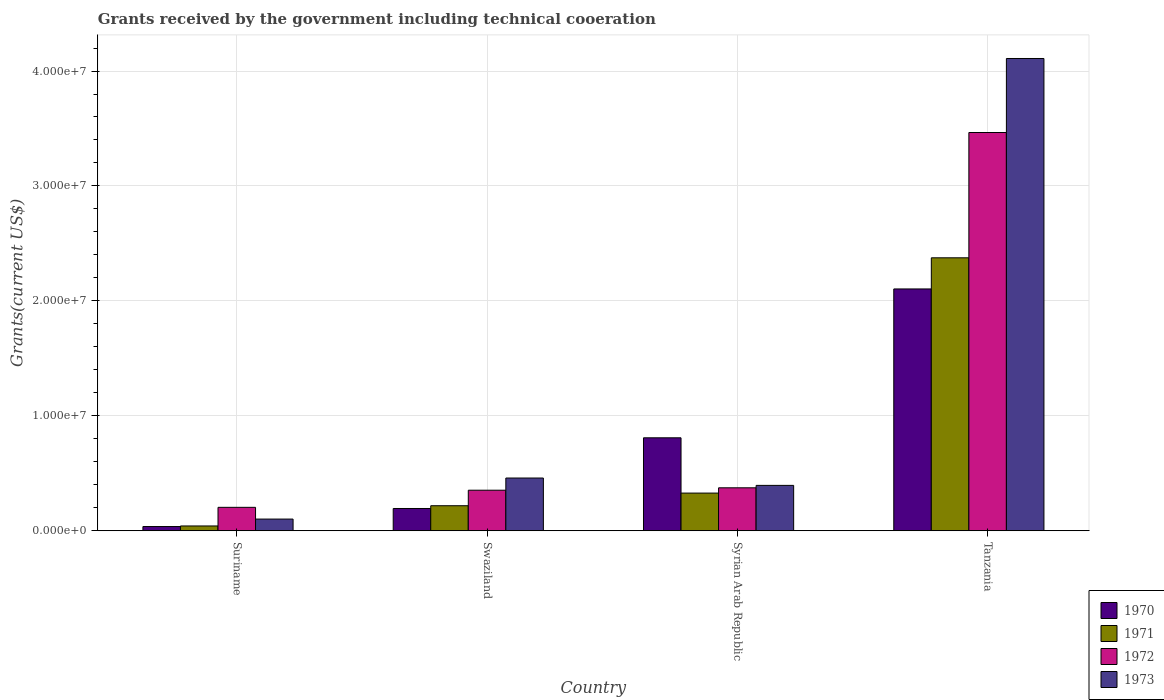Are the number of bars per tick equal to the number of legend labels?
Your answer should be very brief. Yes. Are the number of bars on each tick of the X-axis equal?
Offer a very short reply. Yes. What is the label of the 4th group of bars from the left?
Your answer should be very brief. Tanzania. In how many cases, is the number of bars for a given country not equal to the number of legend labels?
Provide a succinct answer. 0. What is the total grants received by the government in 1973 in Suriname?
Provide a short and direct response. 1.02e+06. Across all countries, what is the maximum total grants received by the government in 1972?
Offer a very short reply. 3.46e+07. In which country was the total grants received by the government in 1971 maximum?
Offer a terse response. Tanzania. In which country was the total grants received by the government in 1970 minimum?
Ensure brevity in your answer.  Suriname. What is the total total grants received by the government in 1972 in the graph?
Your answer should be compact. 4.40e+07. What is the difference between the total grants received by the government in 1973 in Suriname and that in Swaziland?
Your response must be concise. -3.57e+06. What is the difference between the total grants received by the government in 1971 in Tanzania and the total grants received by the government in 1973 in Syrian Arab Republic?
Your response must be concise. 1.98e+07. What is the average total grants received by the government in 1970 per country?
Provide a short and direct response. 7.86e+06. What is the difference between the total grants received by the government of/in 1971 and total grants received by the government of/in 1970 in Tanzania?
Your answer should be compact. 2.71e+06. In how many countries, is the total grants received by the government in 1973 greater than 14000000 US$?
Make the answer very short. 1. What is the ratio of the total grants received by the government in 1970 in Suriname to that in Tanzania?
Give a very brief answer. 0.02. Is the total grants received by the government in 1970 in Syrian Arab Republic less than that in Tanzania?
Your answer should be very brief. Yes. What is the difference between the highest and the second highest total grants received by the government in 1972?
Your response must be concise. 3.11e+07. What is the difference between the highest and the lowest total grants received by the government in 1971?
Provide a succinct answer. 2.33e+07. In how many countries, is the total grants received by the government in 1972 greater than the average total grants received by the government in 1972 taken over all countries?
Provide a short and direct response. 1. Is it the case that in every country, the sum of the total grants received by the government in 1971 and total grants received by the government in 1973 is greater than the sum of total grants received by the government in 1970 and total grants received by the government in 1972?
Your answer should be very brief. No. Is it the case that in every country, the sum of the total grants received by the government in 1970 and total grants received by the government in 1971 is greater than the total grants received by the government in 1972?
Ensure brevity in your answer.  No. How many bars are there?
Give a very brief answer. 16. Are the values on the major ticks of Y-axis written in scientific E-notation?
Ensure brevity in your answer.  Yes. Does the graph contain any zero values?
Your answer should be very brief. No. Where does the legend appear in the graph?
Provide a short and direct response. Bottom right. What is the title of the graph?
Offer a terse response. Grants received by the government including technical cooeration. What is the label or title of the X-axis?
Offer a terse response. Country. What is the label or title of the Y-axis?
Give a very brief answer. Grants(current US$). What is the Grants(current US$) in 1970 in Suriname?
Ensure brevity in your answer.  3.70e+05. What is the Grants(current US$) of 1971 in Suriname?
Offer a very short reply. 4.20e+05. What is the Grants(current US$) of 1972 in Suriname?
Your answer should be compact. 2.04e+06. What is the Grants(current US$) of 1973 in Suriname?
Your answer should be compact. 1.02e+06. What is the Grants(current US$) of 1970 in Swaziland?
Keep it short and to the point. 1.94e+06. What is the Grants(current US$) of 1971 in Swaziland?
Your answer should be very brief. 2.18e+06. What is the Grants(current US$) in 1972 in Swaziland?
Offer a terse response. 3.53e+06. What is the Grants(current US$) of 1973 in Swaziland?
Your answer should be very brief. 4.59e+06. What is the Grants(current US$) in 1970 in Syrian Arab Republic?
Your response must be concise. 8.09e+06. What is the Grants(current US$) in 1971 in Syrian Arab Republic?
Give a very brief answer. 3.28e+06. What is the Grants(current US$) of 1972 in Syrian Arab Republic?
Provide a succinct answer. 3.74e+06. What is the Grants(current US$) in 1973 in Syrian Arab Republic?
Provide a short and direct response. 3.95e+06. What is the Grants(current US$) in 1970 in Tanzania?
Your answer should be compact. 2.10e+07. What is the Grants(current US$) in 1971 in Tanzania?
Your answer should be very brief. 2.38e+07. What is the Grants(current US$) of 1972 in Tanzania?
Your answer should be compact. 3.46e+07. What is the Grants(current US$) in 1973 in Tanzania?
Give a very brief answer. 4.11e+07. Across all countries, what is the maximum Grants(current US$) in 1970?
Ensure brevity in your answer.  2.10e+07. Across all countries, what is the maximum Grants(current US$) of 1971?
Keep it short and to the point. 2.38e+07. Across all countries, what is the maximum Grants(current US$) in 1972?
Keep it short and to the point. 3.46e+07. Across all countries, what is the maximum Grants(current US$) in 1973?
Provide a short and direct response. 4.11e+07. Across all countries, what is the minimum Grants(current US$) in 1970?
Your answer should be very brief. 3.70e+05. Across all countries, what is the minimum Grants(current US$) in 1972?
Ensure brevity in your answer.  2.04e+06. Across all countries, what is the minimum Grants(current US$) in 1973?
Provide a short and direct response. 1.02e+06. What is the total Grants(current US$) in 1970 in the graph?
Ensure brevity in your answer.  3.14e+07. What is the total Grants(current US$) of 1971 in the graph?
Provide a succinct answer. 2.96e+07. What is the total Grants(current US$) of 1972 in the graph?
Keep it short and to the point. 4.40e+07. What is the total Grants(current US$) in 1973 in the graph?
Offer a terse response. 5.06e+07. What is the difference between the Grants(current US$) of 1970 in Suriname and that in Swaziland?
Your answer should be compact. -1.57e+06. What is the difference between the Grants(current US$) in 1971 in Suriname and that in Swaziland?
Your answer should be very brief. -1.76e+06. What is the difference between the Grants(current US$) in 1972 in Suriname and that in Swaziland?
Provide a short and direct response. -1.49e+06. What is the difference between the Grants(current US$) of 1973 in Suriname and that in Swaziland?
Your answer should be compact. -3.57e+06. What is the difference between the Grants(current US$) of 1970 in Suriname and that in Syrian Arab Republic?
Provide a short and direct response. -7.72e+06. What is the difference between the Grants(current US$) of 1971 in Suriname and that in Syrian Arab Republic?
Offer a very short reply. -2.86e+06. What is the difference between the Grants(current US$) in 1972 in Suriname and that in Syrian Arab Republic?
Provide a succinct answer. -1.70e+06. What is the difference between the Grants(current US$) in 1973 in Suriname and that in Syrian Arab Republic?
Your answer should be very brief. -2.93e+06. What is the difference between the Grants(current US$) in 1970 in Suriname and that in Tanzania?
Your answer should be very brief. -2.07e+07. What is the difference between the Grants(current US$) in 1971 in Suriname and that in Tanzania?
Ensure brevity in your answer.  -2.33e+07. What is the difference between the Grants(current US$) of 1972 in Suriname and that in Tanzania?
Your response must be concise. -3.26e+07. What is the difference between the Grants(current US$) in 1973 in Suriname and that in Tanzania?
Your answer should be compact. -4.01e+07. What is the difference between the Grants(current US$) in 1970 in Swaziland and that in Syrian Arab Republic?
Provide a short and direct response. -6.15e+06. What is the difference between the Grants(current US$) in 1971 in Swaziland and that in Syrian Arab Republic?
Offer a terse response. -1.10e+06. What is the difference between the Grants(current US$) of 1973 in Swaziland and that in Syrian Arab Republic?
Make the answer very short. 6.40e+05. What is the difference between the Grants(current US$) of 1970 in Swaziland and that in Tanzania?
Offer a terse response. -1.91e+07. What is the difference between the Grants(current US$) in 1971 in Swaziland and that in Tanzania?
Ensure brevity in your answer.  -2.16e+07. What is the difference between the Grants(current US$) of 1972 in Swaziland and that in Tanzania?
Your answer should be very brief. -3.11e+07. What is the difference between the Grants(current US$) of 1973 in Swaziland and that in Tanzania?
Make the answer very short. -3.65e+07. What is the difference between the Grants(current US$) of 1970 in Syrian Arab Republic and that in Tanzania?
Offer a very short reply. -1.30e+07. What is the difference between the Grants(current US$) in 1971 in Syrian Arab Republic and that in Tanzania?
Provide a short and direct response. -2.05e+07. What is the difference between the Grants(current US$) in 1972 in Syrian Arab Republic and that in Tanzania?
Keep it short and to the point. -3.09e+07. What is the difference between the Grants(current US$) in 1973 in Syrian Arab Republic and that in Tanzania?
Keep it short and to the point. -3.71e+07. What is the difference between the Grants(current US$) in 1970 in Suriname and the Grants(current US$) in 1971 in Swaziland?
Offer a terse response. -1.81e+06. What is the difference between the Grants(current US$) in 1970 in Suriname and the Grants(current US$) in 1972 in Swaziland?
Your response must be concise. -3.16e+06. What is the difference between the Grants(current US$) in 1970 in Suriname and the Grants(current US$) in 1973 in Swaziland?
Provide a short and direct response. -4.22e+06. What is the difference between the Grants(current US$) of 1971 in Suriname and the Grants(current US$) of 1972 in Swaziland?
Your answer should be very brief. -3.11e+06. What is the difference between the Grants(current US$) of 1971 in Suriname and the Grants(current US$) of 1973 in Swaziland?
Ensure brevity in your answer.  -4.17e+06. What is the difference between the Grants(current US$) of 1972 in Suriname and the Grants(current US$) of 1973 in Swaziland?
Your response must be concise. -2.55e+06. What is the difference between the Grants(current US$) in 1970 in Suriname and the Grants(current US$) in 1971 in Syrian Arab Republic?
Your answer should be very brief. -2.91e+06. What is the difference between the Grants(current US$) in 1970 in Suriname and the Grants(current US$) in 1972 in Syrian Arab Republic?
Give a very brief answer. -3.37e+06. What is the difference between the Grants(current US$) of 1970 in Suriname and the Grants(current US$) of 1973 in Syrian Arab Republic?
Provide a succinct answer. -3.58e+06. What is the difference between the Grants(current US$) in 1971 in Suriname and the Grants(current US$) in 1972 in Syrian Arab Republic?
Offer a very short reply. -3.32e+06. What is the difference between the Grants(current US$) in 1971 in Suriname and the Grants(current US$) in 1973 in Syrian Arab Republic?
Provide a succinct answer. -3.53e+06. What is the difference between the Grants(current US$) of 1972 in Suriname and the Grants(current US$) of 1973 in Syrian Arab Republic?
Make the answer very short. -1.91e+06. What is the difference between the Grants(current US$) of 1970 in Suriname and the Grants(current US$) of 1971 in Tanzania?
Offer a very short reply. -2.34e+07. What is the difference between the Grants(current US$) of 1970 in Suriname and the Grants(current US$) of 1972 in Tanzania?
Ensure brevity in your answer.  -3.43e+07. What is the difference between the Grants(current US$) in 1970 in Suriname and the Grants(current US$) in 1973 in Tanzania?
Keep it short and to the point. -4.07e+07. What is the difference between the Grants(current US$) in 1971 in Suriname and the Grants(current US$) in 1972 in Tanzania?
Offer a terse response. -3.42e+07. What is the difference between the Grants(current US$) of 1971 in Suriname and the Grants(current US$) of 1973 in Tanzania?
Offer a terse response. -4.07e+07. What is the difference between the Grants(current US$) in 1972 in Suriname and the Grants(current US$) in 1973 in Tanzania?
Offer a terse response. -3.90e+07. What is the difference between the Grants(current US$) of 1970 in Swaziland and the Grants(current US$) of 1971 in Syrian Arab Republic?
Your response must be concise. -1.34e+06. What is the difference between the Grants(current US$) in 1970 in Swaziland and the Grants(current US$) in 1972 in Syrian Arab Republic?
Your response must be concise. -1.80e+06. What is the difference between the Grants(current US$) in 1970 in Swaziland and the Grants(current US$) in 1973 in Syrian Arab Republic?
Ensure brevity in your answer.  -2.01e+06. What is the difference between the Grants(current US$) in 1971 in Swaziland and the Grants(current US$) in 1972 in Syrian Arab Republic?
Give a very brief answer. -1.56e+06. What is the difference between the Grants(current US$) of 1971 in Swaziland and the Grants(current US$) of 1973 in Syrian Arab Republic?
Offer a very short reply. -1.77e+06. What is the difference between the Grants(current US$) in 1972 in Swaziland and the Grants(current US$) in 1973 in Syrian Arab Republic?
Your answer should be very brief. -4.20e+05. What is the difference between the Grants(current US$) of 1970 in Swaziland and the Grants(current US$) of 1971 in Tanzania?
Your answer should be compact. -2.18e+07. What is the difference between the Grants(current US$) of 1970 in Swaziland and the Grants(current US$) of 1972 in Tanzania?
Offer a very short reply. -3.27e+07. What is the difference between the Grants(current US$) of 1970 in Swaziland and the Grants(current US$) of 1973 in Tanzania?
Your response must be concise. -3.92e+07. What is the difference between the Grants(current US$) in 1971 in Swaziland and the Grants(current US$) in 1972 in Tanzania?
Keep it short and to the point. -3.25e+07. What is the difference between the Grants(current US$) of 1971 in Swaziland and the Grants(current US$) of 1973 in Tanzania?
Your answer should be very brief. -3.89e+07. What is the difference between the Grants(current US$) in 1972 in Swaziland and the Grants(current US$) in 1973 in Tanzania?
Provide a succinct answer. -3.76e+07. What is the difference between the Grants(current US$) in 1970 in Syrian Arab Republic and the Grants(current US$) in 1971 in Tanzania?
Provide a succinct answer. -1.57e+07. What is the difference between the Grants(current US$) of 1970 in Syrian Arab Republic and the Grants(current US$) of 1972 in Tanzania?
Keep it short and to the point. -2.66e+07. What is the difference between the Grants(current US$) in 1970 in Syrian Arab Republic and the Grants(current US$) in 1973 in Tanzania?
Your response must be concise. -3.30e+07. What is the difference between the Grants(current US$) in 1971 in Syrian Arab Republic and the Grants(current US$) in 1972 in Tanzania?
Your answer should be compact. -3.14e+07. What is the difference between the Grants(current US$) in 1971 in Syrian Arab Republic and the Grants(current US$) in 1973 in Tanzania?
Make the answer very short. -3.78e+07. What is the difference between the Grants(current US$) in 1972 in Syrian Arab Republic and the Grants(current US$) in 1973 in Tanzania?
Your response must be concise. -3.74e+07. What is the average Grants(current US$) in 1970 per country?
Your answer should be very brief. 7.86e+06. What is the average Grants(current US$) of 1971 per country?
Keep it short and to the point. 7.41e+06. What is the average Grants(current US$) of 1972 per country?
Offer a very short reply. 1.10e+07. What is the average Grants(current US$) in 1973 per country?
Your response must be concise. 1.27e+07. What is the difference between the Grants(current US$) in 1970 and Grants(current US$) in 1971 in Suriname?
Make the answer very short. -5.00e+04. What is the difference between the Grants(current US$) of 1970 and Grants(current US$) of 1972 in Suriname?
Make the answer very short. -1.67e+06. What is the difference between the Grants(current US$) in 1970 and Grants(current US$) in 1973 in Suriname?
Your answer should be compact. -6.50e+05. What is the difference between the Grants(current US$) in 1971 and Grants(current US$) in 1972 in Suriname?
Your answer should be very brief. -1.62e+06. What is the difference between the Grants(current US$) of 1971 and Grants(current US$) of 1973 in Suriname?
Offer a terse response. -6.00e+05. What is the difference between the Grants(current US$) in 1972 and Grants(current US$) in 1973 in Suriname?
Your response must be concise. 1.02e+06. What is the difference between the Grants(current US$) in 1970 and Grants(current US$) in 1971 in Swaziland?
Offer a very short reply. -2.40e+05. What is the difference between the Grants(current US$) of 1970 and Grants(current US$) of 1972 in Swaziland?
Offer a terse response. -1.59e+06. What is the difference between the Grants(current US$) in 1970 and Grants(current US$) in 1973 in Swaziland?
Offer a very short reply. -2.65e+06. What is the difference between the Grants(current US$) in 1971 and Grants(current US$) in 1972 in Swaziland?
Your answer should be very brief. -1.35e+06. What is the difference between the Grants(current US$) of 1971 and Grants(current US$) of 1973 in Swaziland?
Provide a succinct answer. -2.41e+06. What is the difference between the Grants(current US$) in 1972 and Grants(current US$) in 1973 in Swaziland?
Offer a very short reply. -1.06e+06. What is the difference between the Grants(current US$) of 1970 and Grants(current US$) of 1971 in Syrian Arab Republic?
Make the answer very short. 4.81e+06. What is the difference between the Grants(current US$) in 1970 and Grants(current US$) in 1972 in Syrian Arab Republic?
Make the answer very short. 4.35e+06. What is the difference between the Grants(current US$) of 1970 and Grants(current US$) of 1973 in Syrian Arab Republic?
Provide a short and direct response. 4.14e+06. What is the difference between the Grants(current US$) of 1971 and Grants(current US$) of 1972 in Syrian Arab Republic?
Ensure brevity in your answer.  -4.60e+05. What is the difference between the Grants(current US$) of 1971 and Grants(current US$) of 1973 in Syrian Arab Republic?
Your answer should be compact. -6.70e+05. What is the difference between the Grants(current US$) in 1972 and Grants(current US$) in 1973 in Syrian Arab Republic?
Your answer should be very brief. -2.10e+05. What is the difference between the Grants(current US$) of 1970 and Grants(current US$) of 1971 in Tanzania?
Your answer should be very brief. -2.71e+06. What is the difference between the Grants(current US$) in 1970 and Grants(current US$) in 1972 in Tanzania?
Ensure brevity in your answer.  -1.36e+07. What is the difference between the Grants(current US$) of 1970 and Grants(current US$) of 1973 in Tanzania?
Keep it short and to the point. -2.00e+07. What is the difference between the Grants(current US$) in 1971 and Grants(current US$) in 1972 in Tanzania?
Your answer should be very brief. -1.09e+07. What is the difference between the Grants(current US$) of 1971 and Grants(current US$) of 1973 in Tanzania?
Ensure brevity in your answer.  -1.73e+07. What is the difference between the Grants(current US$) of 1972 and Grants(current US$) of 1973 in Tanzania?
Your answer should be compact. -6.44e+06. What is the ratio of the Grants(current US$) of 1970 in Suriname to that in Swaziland?
Keep it short and to the point. 0.19. What is the ratio of the Grants(current US$) in 1971 in Suriname to that in Swaziland?
Your response must be concise. 0.19. What is the ratio of the Grants(current US$) of 1972 in Suriname to that in Swaziland?
Offer a terse response. 0.58. What is the ratio of the Grants(current US$) of 1973 in Suriname to that in Swaziland?
Offer a terse response. 0.22. What is the ratio of the Grants(current US$) in 1970 in Suriname to that in Syrian Arab Republic?
Your response must be concise. 0.05. What is the ratio of the Grants(current US$) in 1971 in Suriname to that in Syrian Arab Republic?
Your response must be concise. 0.13. What is the ratio of the Grants(current US$) of 1972 in Suriname to that in Syrian Arab Republic?
Offer a terse response. 0.55. What is the ratio of the Grants(current US$) of 1973 in Suriname to that in Syrian Arab Republic?
Offer a terse response. 0.26. What is the ratio of the Grants(current US$) of 1970 in Suriname to that in Tanzania?
Keep it short and to the point. 0.02. What is the ratio of the Grants(current US$) of 1971 in Suriname to that in Tanzania?
Make the answer very short. 0.02. What is the ratio of the Grants(current US$) in 1972 in Suriname to that in Tanzania?
Offer a very short reply. 0.06. What is the ratio of the Grants(current US$) of 1973 in Suriname to that in Tanzania?
Provide a succinct answer. 0.02. What is the ratio of the Grants(current US$) of 1970 in Swaziland to that in Syrian Arab Republic?
Provide a short and direct response. 0.24. What is the ratio of the Grants(current US$) of 1971 in Swaziland to that in Syrian Arab Republic?
Your answer should be compact. 0.66. What is the ratio of the Grants(current US$) in 1972 in Swaziland to that in Syrian Arab Republic?
Provide a succinct answer. 0.94. What is the ratio of the Grants(current US$) in 1973 in Swaziland to that in Syrian Arab Republic?
Offer a very short reply. 1.16. What is the ratio of the Grants(current US$) of 1970 in Swaziland to that in Tanzania?
Ensure brevity in your answer.  0.09. What is the ratio of the Grants(current US$) in 1971 in Swaziland to that in Tanzania?
Ensure brevity in your answer.  0.09. What is the ratio of the Grants(current US$) in 1972 in Swaziland to that in Tanzania?
Provide a short and direct response. 0.1. What is the ratio of the Grants(current US$) of 1973 in Swaziland to that in Tanzania?
Keep it short and to the point. 0.11. What is the ratio of the Grants(current US$) of 1970 in Syrian Arab Republic to that in Tanzania?
Your response must be concise. 0.38. What is the ratio of the Grants(current US$) of 1971 in Syrian Arab Republic to that in Tanzania?
Ensure brevity in your answer.  0.14. What is the ratio of the Grants(current US$) of 1972 in Syrian Arab Republic to that in Tanzania?
Offer a terse response. 0.11. What is the ratio of the Grants(current US$) in 1973 in Syrian Arab Republic to that in Tanzania?
Make the answer very short. 0.1. What is the difference between the highest and the second highest Grants(current US$) in 1970?
Keep it short and to the point. 1.30e+07. What is the difference between the highest and the second highest Grants(current US$) of 1971?
Your answer should be compact. 2.05e+07. What is the difference between the highest and the second highest Grants(current US$) in 1972?
Keep it short and to the point. 3.09e+07. What is the difference between the highest and the second highest Grants(current US$) of 1973?
Offer a very short reply. 3.65e+07. What is the difference between the highest and the lowest Grants(current US$) in 1970?
Make the answer very short. 2.07e+07. What is the difference between the highest and the lowest Grants(current US$) in 1971?
Ensure brevity in your answer.  2.33e+07. What is the difference between the highest and the lowest Grants(current US$) in 1972?
Your response must be concise. 3.26e+07. What is the difference between the highest and the lowest Grants(current US$) of 1973?
Provide a short and direct response. 4.01e+07. 